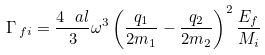Convert formula to latex. <formula><loc_0><loc_0><loc_500><loc_500>\Gamma _ { \, f i } = \frac { 4 \ a l } { 3 } \omega ^ { 3 } \left ( \frac { q _ { 1 } } { 2 m _ { 1 } } - \frac { q _ { 2 } } { 2 m _ { 2 } } \right ) ^ { 2 } \frac { E _ { f } } { M _ { i } }</formula> 